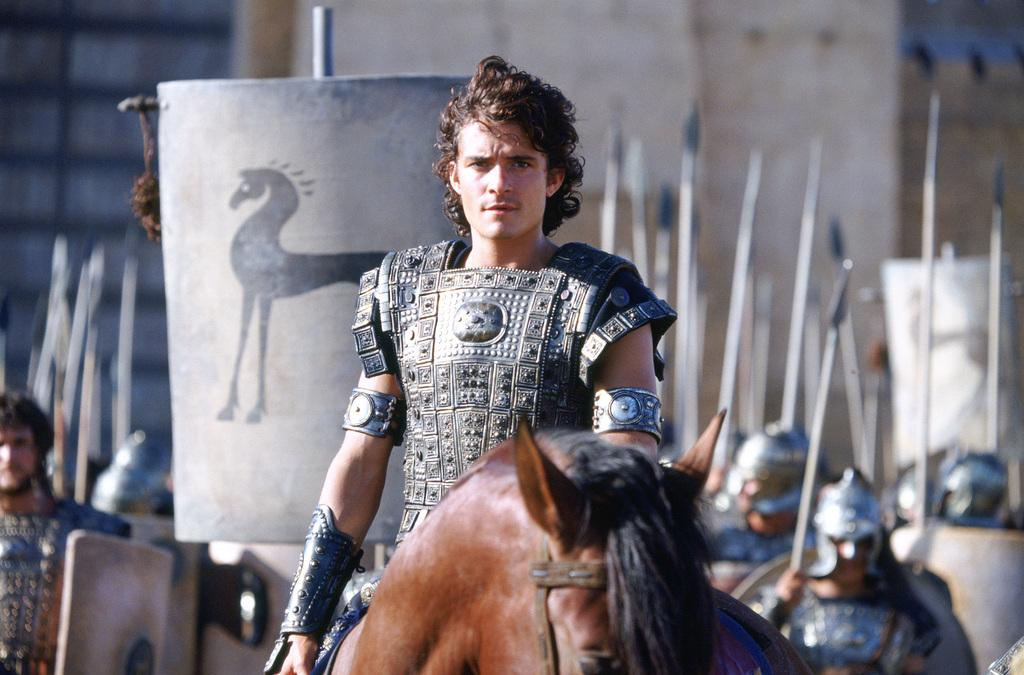What is the man in the image doing? The man is sitting on a horse in the image. What is the man wearing? The man is wearing an armed dress. What can be seen in the background of the image? In the background, there are many persons standing. What are the persons in the background holding? The persons in the background are holding swords and shields. What type of headgear are the persons in the background wearing? The persons in the background are wearing helmets. What type of pies are being baked by the man on the horse in the image? There is no mention of pies or baking in the image; the man is sitting on a horse and wearing an armed dress. 